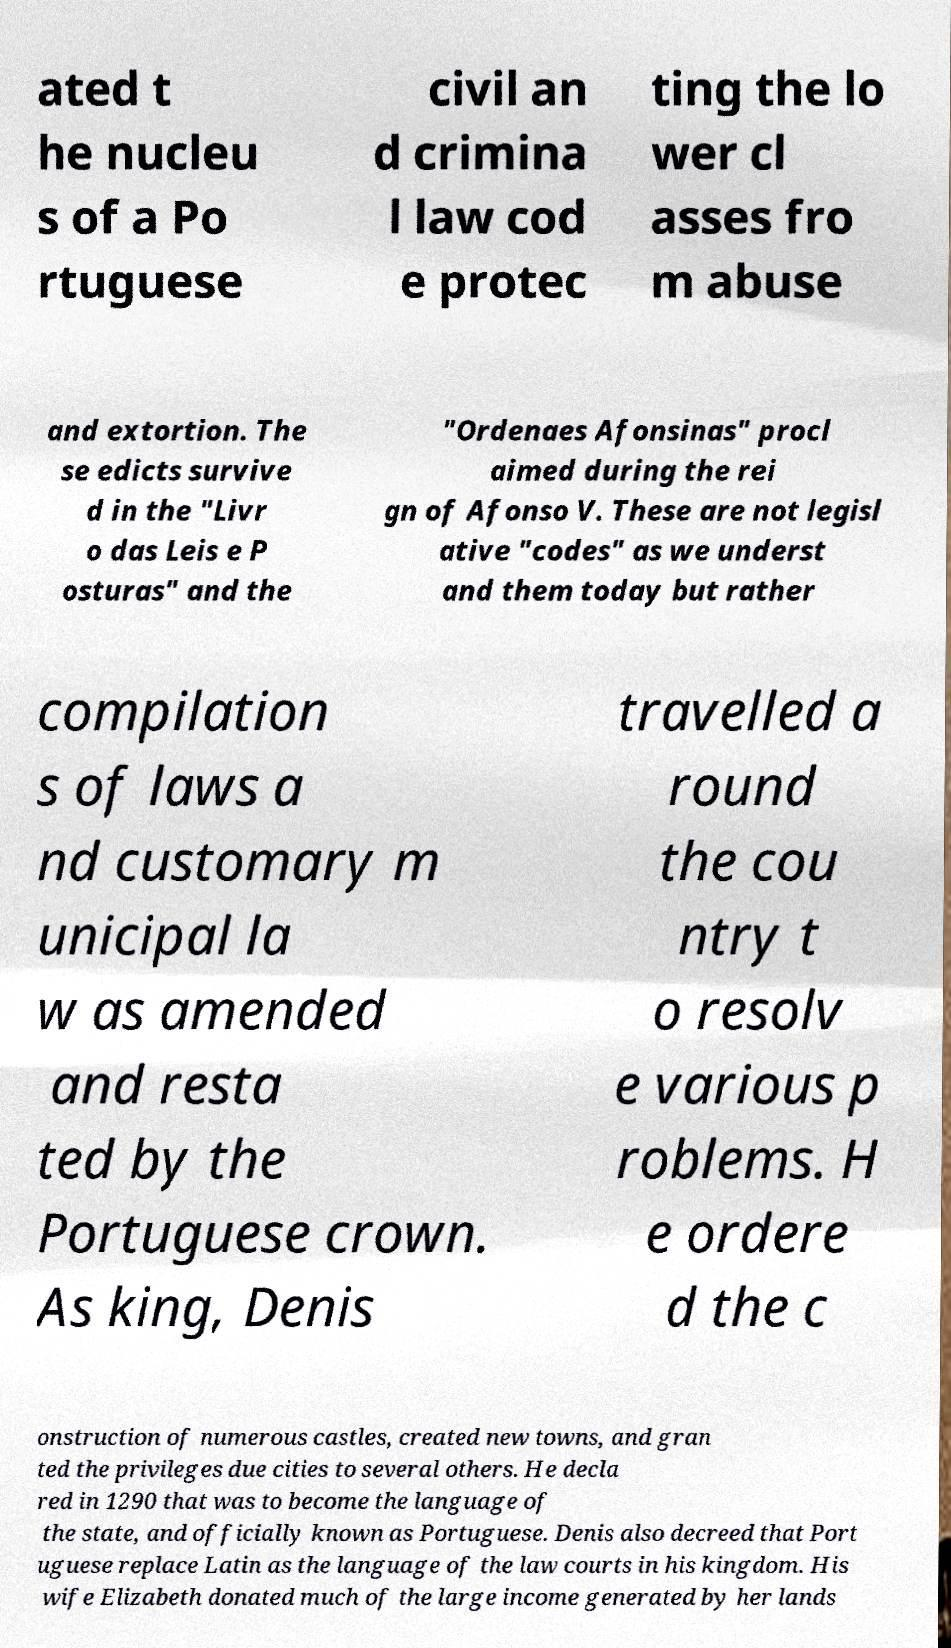I need the written content from this picture converted into text. Can you do that? ated t he nucleu s of a Po rtuguese civil an d crimina l law cod e protec ting the lo wer cl asses fro m abuse and extortion. The se edicts survive d in the "Livr o das Leis e P osturas" and the "Ordenaes Afonsinas" procl aimed during the rei gn of Afonso V. These are not legisl ative "codes" as we underst and them today but rather compilation s of laws a nd customary m unicipal la w as amended and resta ted by the Portuguese crown. As king, Denis travelled a round the cou ntry t o resolv e various p roblems. H e ordere d the c onstruction of numerous castles, created new towns, and gran ted the privileges due cities to several others. He decla red in 1290 that was to become the language of the state, and officially known as Portuguese. Denis also decreed that Port uguese replace Latin as the language of the law courts in his kingdom. His wife Elizabeth donated much of the large income generated by her lands 